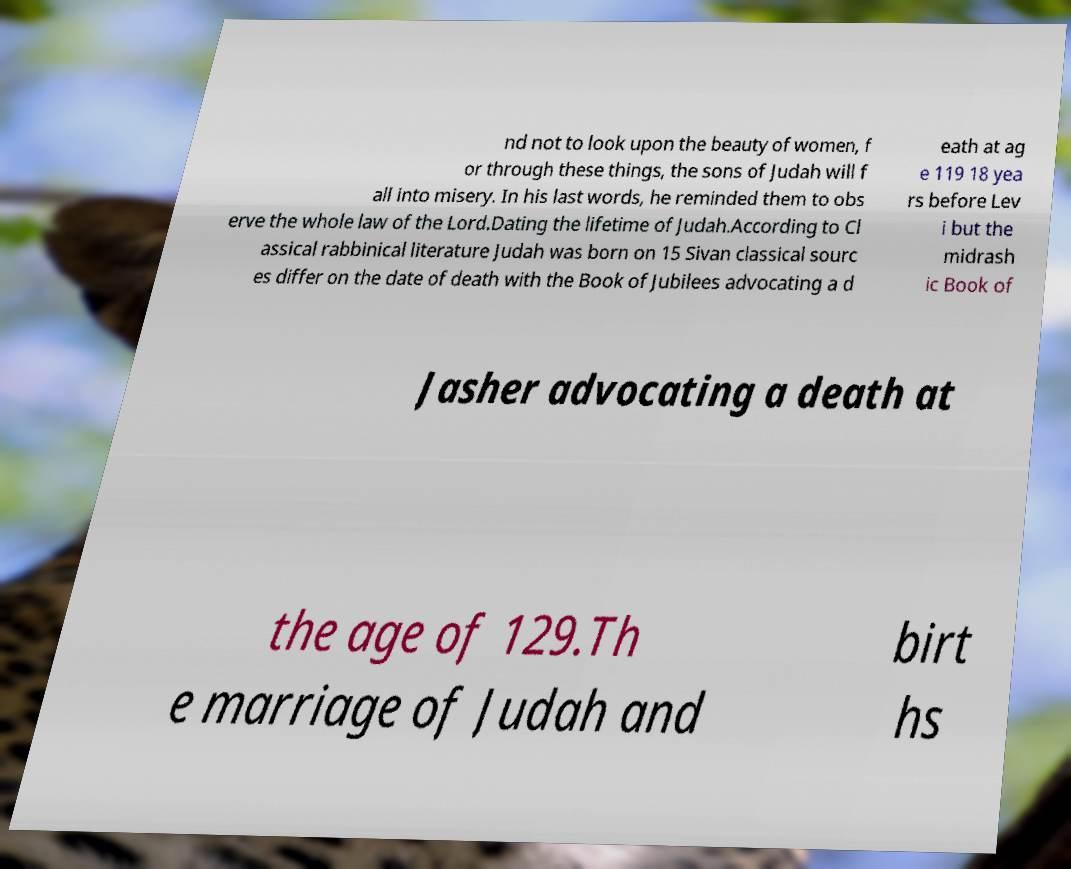For documentation purposes, I need the text within this image transcribed. Could you provide that? nd not to look upon the beauty of women, f or through these things, the sons of Judah will f all into misery. In his last words, he reminded them to obs erve the whole law of the Lord.Dating the lifetime of Judah.According to Cl assical rabbinical literature Judah was born on 15 Sivan classical sourc es differ on the date of death with the Book of Jubilees advocating a d eath at ag e 119 18 yea rs before Lev i but the midrash ic Book of Jasher advocating a death at the age of 129.Th e marriage of Judah and birt hs 